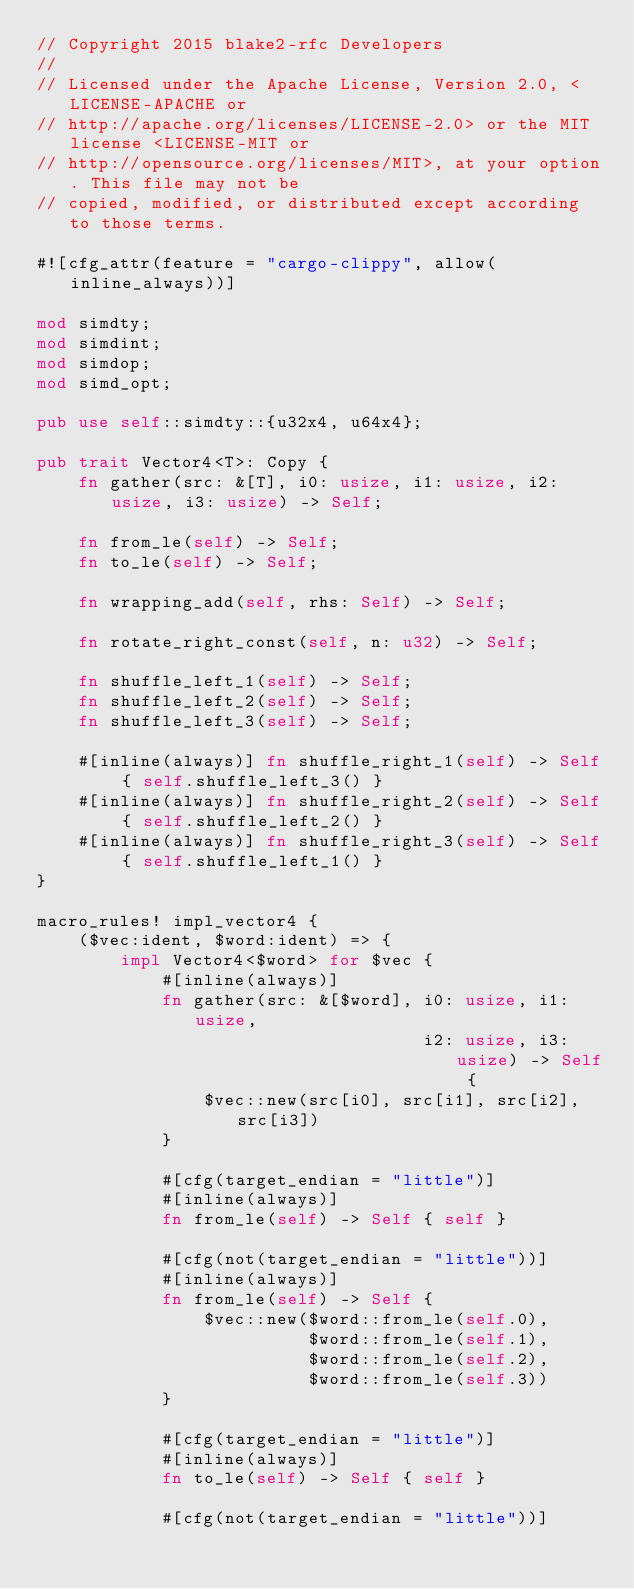<code> <loc_0><loc_0><loc_500><loc_500><_Rust_>// Copyright 2015 blake2-rfc Developers
//
// Licensed under the Apache License, Version 2.0, <LICENSE-APACHE or
// http://apache.org/licenses/LICENSE-2.0> or the MIT license <LICENSE-MIT or
// http://opensource.org/licenses/MIT>, at your option. This file may not be
// copied, modified, or distributed except according to those terms.

#![cfg_attr(feature = "cargo-clippy", allow(inline_always))]

mod simdty;
mod simdint;
mod simdop;
mod simd_opt;

pub use self::simdty::{u32x4, u64x4};

pub trait Vector4<T>: Copy {
    fn gather(src: &[T], i0: usize, i1: usize, i2: usize, i3: usize) -> Self;

    fn from_le(self) -> Self;
    fn to_le(self) -> Self;

    fn wrapping_add(self, rhs: Self) -> Self;

    fn rotate_right_const(self, n: u32) -> Self;

    fn shuffle_left_1(self) -> Self;
    fn shuffle_left_2(self) -> Self;
    fn shuffle_left_3(self) -> Self;

    #[inline(always)] fn shuffle_right_1(self) -> Self { self.shuffle_left_3() }
    #[inline(always)] fn shuffle_right_2(self) -> Self { self.shuffle_left_2() }
    #[inline(always)] fn shuffle_right_3(self) -> Self { self.shuffle_left_1() }
}

macro_rules! impl_vector4 {
    ($vec:ident, $word:ident) => {
        impl Vector4<$word> for $vec {
            #[inline(always)]
            fn gather(src: &[$word], i0: usize, i1: usize,
                                     i2: usize, i3: usize) -> Self {
                $vec::new(src[i0], src[i1], src[i2], src[i3])
            }

            #[cfg(target_endian = "little")]
            #[inline(always)]
            fn from_le(self) -> Self { self }

            #[cfg(not(target_endian = "little"))]
            #[inline(always)]
            fn from_le(self) -> Self {
                $vec::new($word::from_le(self.0),
                          $word::from_le(self.1),
                          $word::from_le(self.2),
                          $word::from_le(self.3))
            }

            #[cfg(target_endian = "little")]
            #[inline(always)]
            fn to_le(self) -> Self { self }

            #[cfg(not(target_endian = "little"))]</code> 